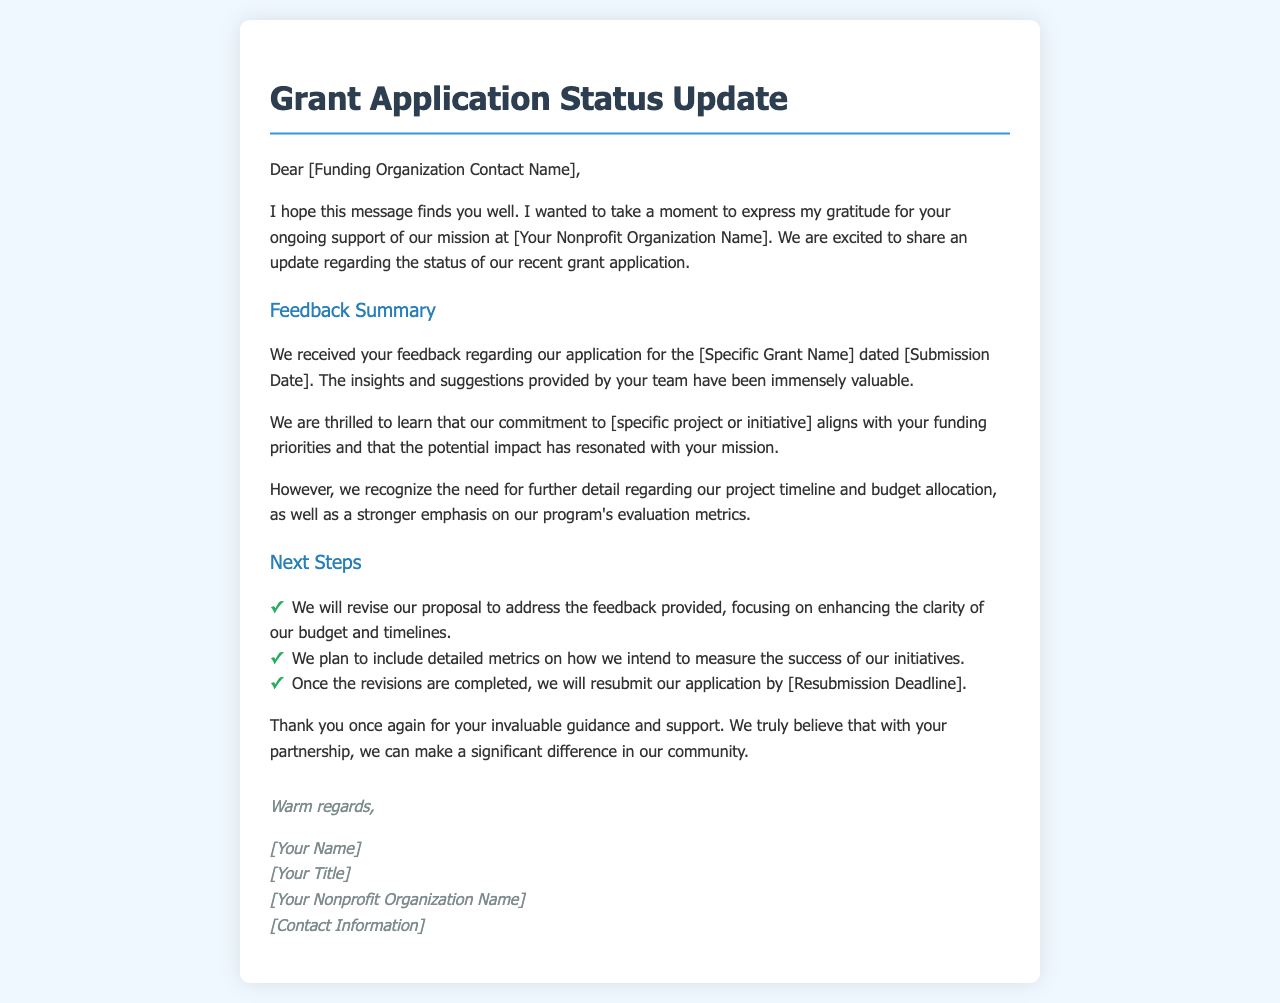What is the title of the document? The title of the document is indicated at the top of the message.
Answer: Grant Application Status Update Who is the main contact for the funding organization? The main contact is referenced at the beginning of the document but is a placeholder.
Answer: [Funding Organization Contact Name] What is the name of the grant applied for? The specific grant name is mentioned in the feedback summary section.
Answer: [Specific Grant Name] What is the submission date of the grant application? The submission date for the grant application is mentioned in the feedback summary.
Answer: [Submission Date] What is the focus of the project that aligns with the funding priorities? The focus of the project is highlighted in the feedback section regarding the organization's mission.
Answer: [specific project or initiative] What are the next steps outlined in the document? Next steps are provided as a list in the following section of the document.
Answer: Resubmit our application by [Resubmission Deadline] What is the primary concern mentioned in the feedback? The primary concern relates to specific aspects of the project that need further detail.
Answer: Project timeline and budget allocation How does the sender express gratitude? The sender expresses gratitude both in the opening and closing remarks of the document.
Answer: Thank you once again for your invaluable guidance and support 